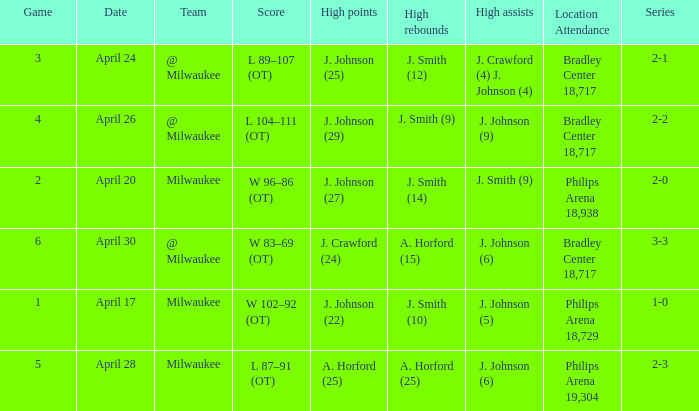What were the amount of rebounds in game 2? J. Smith (14). 